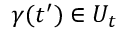Convert formula to latex. <formula><loc_0><loc_0><loc_500><loc_500>\gamma ( t ^ { \prime } ) \in U _ { t }</formula> 